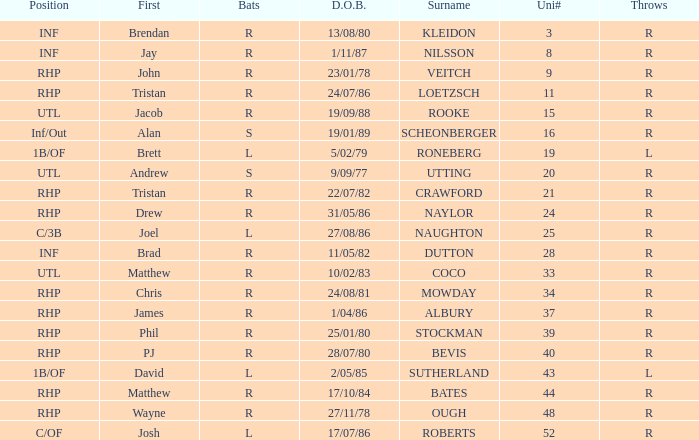Which Surname has Throws of l, and a DOB of 5/02/79? RONEBERG. 